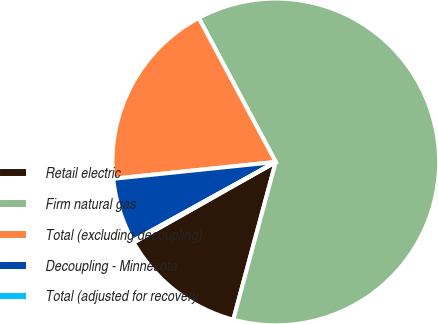Convert chart. <chart><loc_0><loc_0><loc_500><loc_500><pie_chart><fcel>Retail electric<fcel>Firm natural gas<fcel>Total (excluding decoupling)<fcel>Decoupling - Minnesota<fcel>Total (adjusted for recovery<nl><fcel>12.61%<fcel>62.0%<fcel>18.83%<fcel>6.39%<fcel>0.17%<nl></chart> 